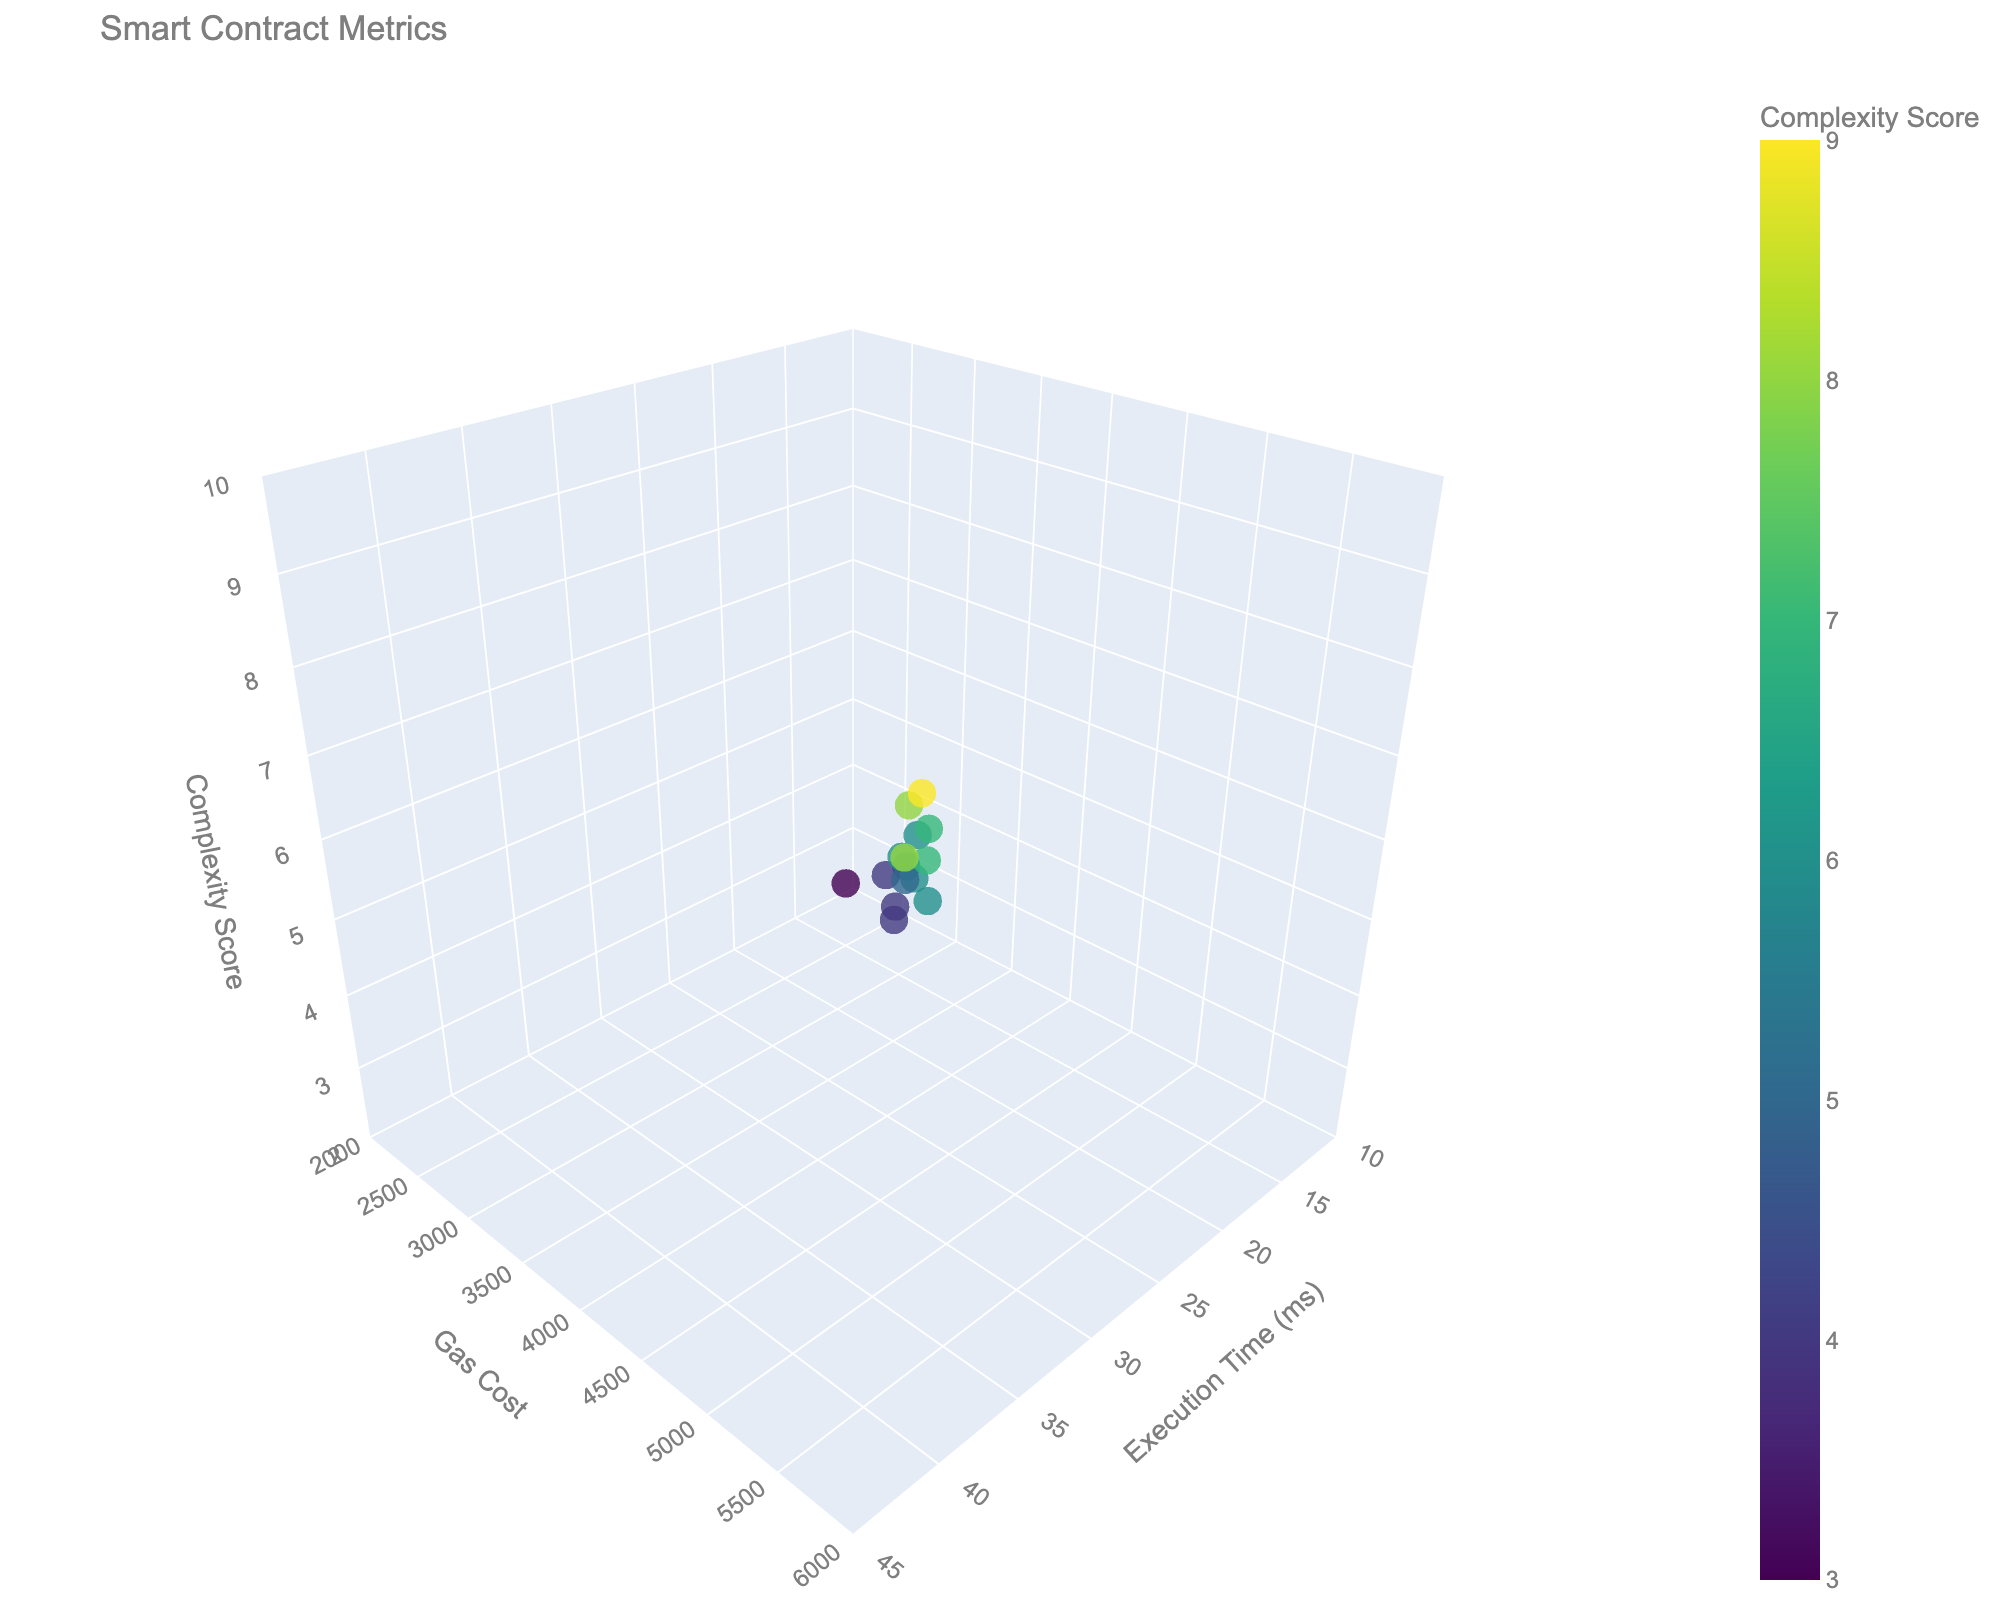Which chaincode has the highest execution time? By looking at the plot, locate the data point with the highest value on the Execution Time (ms) axis and read the associated Chaincode name shown in the hover text.
Answer: HealthcareRecords Which chaincode has a complexity score of 7? Find data points with a z-axis (Complexity Score) value of 7, and check the corresponding Chaincode names in the hover text.
Answer: IdentityManagement, IntellectualProperty What is the range of gas costs represented in the plot? Examine the y-axis (Gas Cost) values to find the minimum and maximum gas costs shown in the figure, which are the lowest and highest points on this axis.
Answer: 2500-5800 Which chaincode has an execution time less than 20 ms and a gas cost greater than 3000? Identify data points that fulfill both conditions: x-axis (Execution Time) less than 20 ms and y-axis (Gas Cost) greater than 3000, then read the Chaincode names in the hover text for those points.
Answer: VotingSystem Which chaincode has the lowest complexity score, and what are its execution time and gas cost? Find the data point with the lowest z-axis (Complexity Score), then look at its x-axis (Execution Time) and y-axis (Gas Cost) values from the hover text.
Answer: AssetTransfer, 15 ms, 2500 How do the gas costs of AuctionPlatform and RealEstateRegistry compare? Compare the y-axis (Gas Cost) values of the data points for AuctionPlatform and RealEstateRegistry; AuctionPlatform's gas cost is higher.
Answer: AuctionPlatform > RealEstateRegistry What is the average execution time of chaincodes with a complexity score of 6? Identify data points with a z-axis (Complexity Score) of 6, extract the x-axis (Execution Time) values, and calculate the average of these values. (25 ms + 28 ms + 27 ms + 29 ms) / 4 = 27.25 ms
Answer: 27.25 ms Is there a correlation between execution time and complexity score? Observe if there is an upward or downward trend in the data points from the x-axis (Execution Time) to the z-axis (Complexity Score). There is a positive correlation as higher execution times generally correspond to higher complexity scores.
Answer: Yes, positive correlation Which chaincode has the highest gas cost and what are its execution time and complexity score? Locate the data point with the highest y-axis (Gas Cost) value, then find its x-axis (Execution Time) and z-axis (Complexity Score) values from the hover text.
Answer: HealthcareRecords, 40 ms, 9 